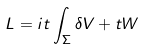<formula> <loc_0><loc_0><loc_500><loc_500>L = i t \int _ { \Sigma } \delta V + t W</formula> 